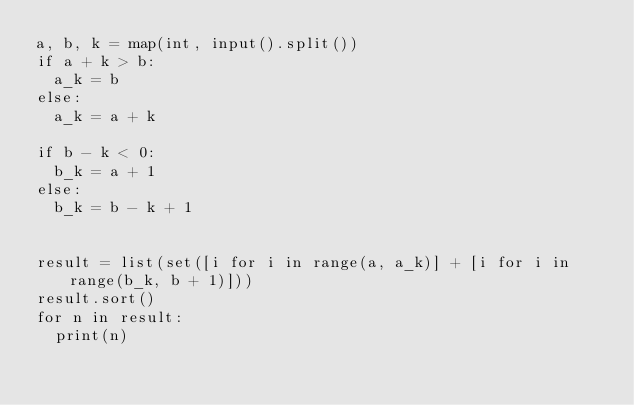<code> <loc_0><loc_0><loc_500><loc_500><_Python_>a, b, k = map(int, input().split())
if a + k > b:
  a_k = b
else:
  a_k = a + k

if b - k < 0:
  b_k = a + 1
else:
  b_k = b - k + 1


result = list(set([i for i in range(a, a_k)] + [i for i in range(b_k, b + 1)]))
result.sort()
for n in result:
  print(n)
</code> 